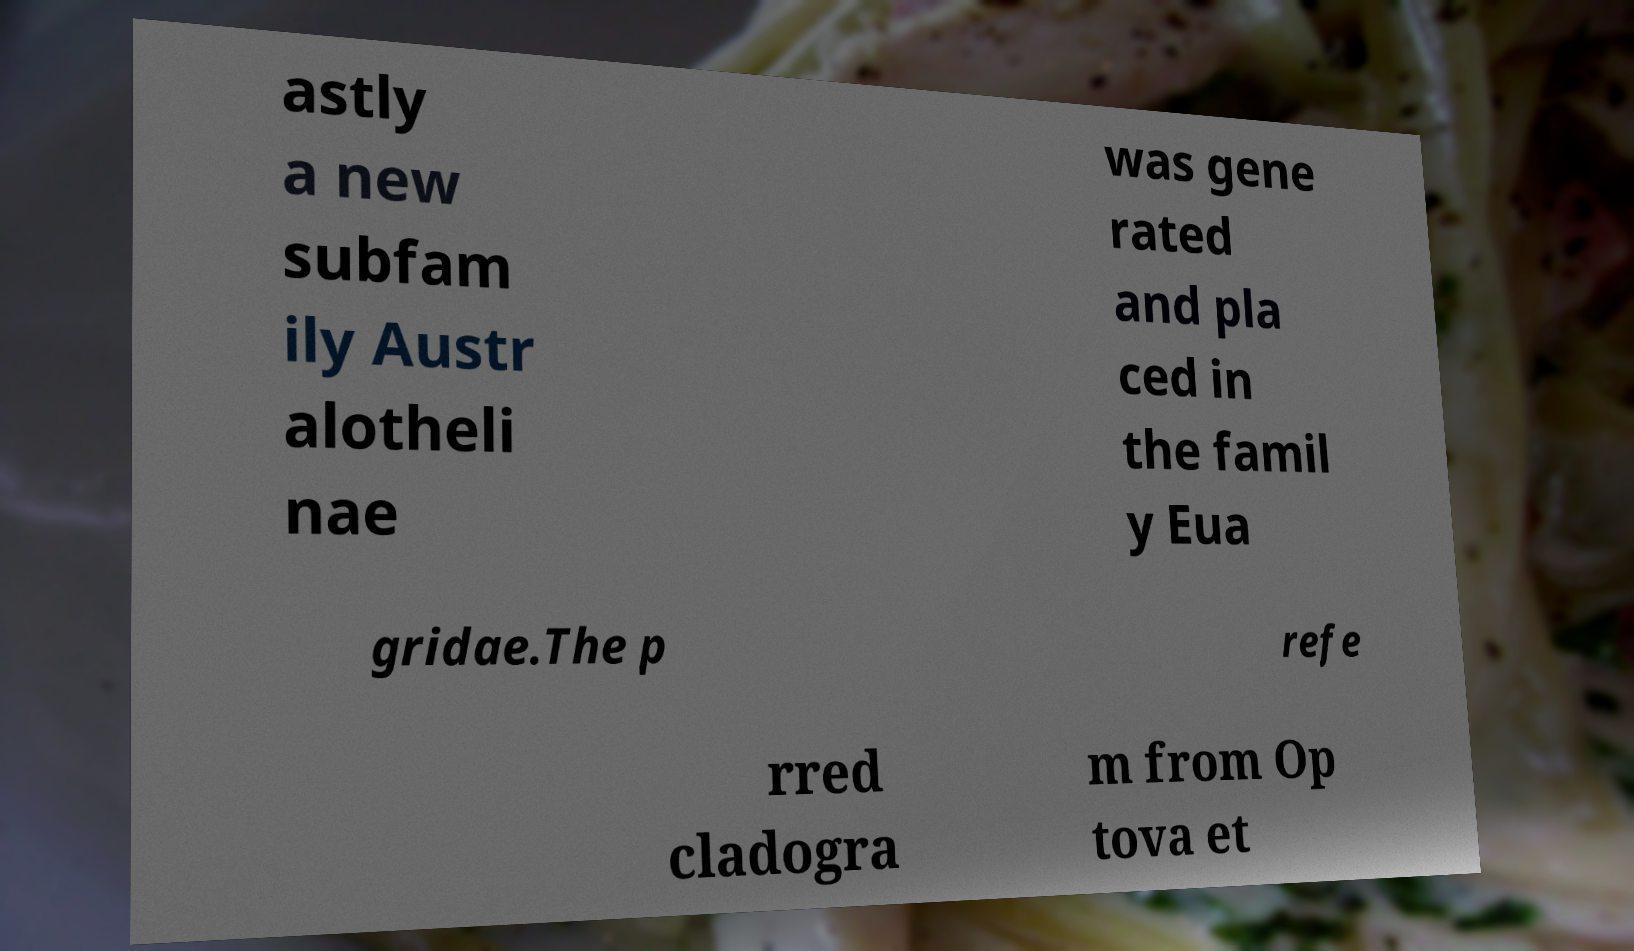There's text embedded in this image that I need extracted. Can you transcribe it verbatim? astly a new subfam ily Austr alotheli nae was gene rated and pla ced in the famil y Eua gridae.The p refe rred cladogra m from Op tova et 